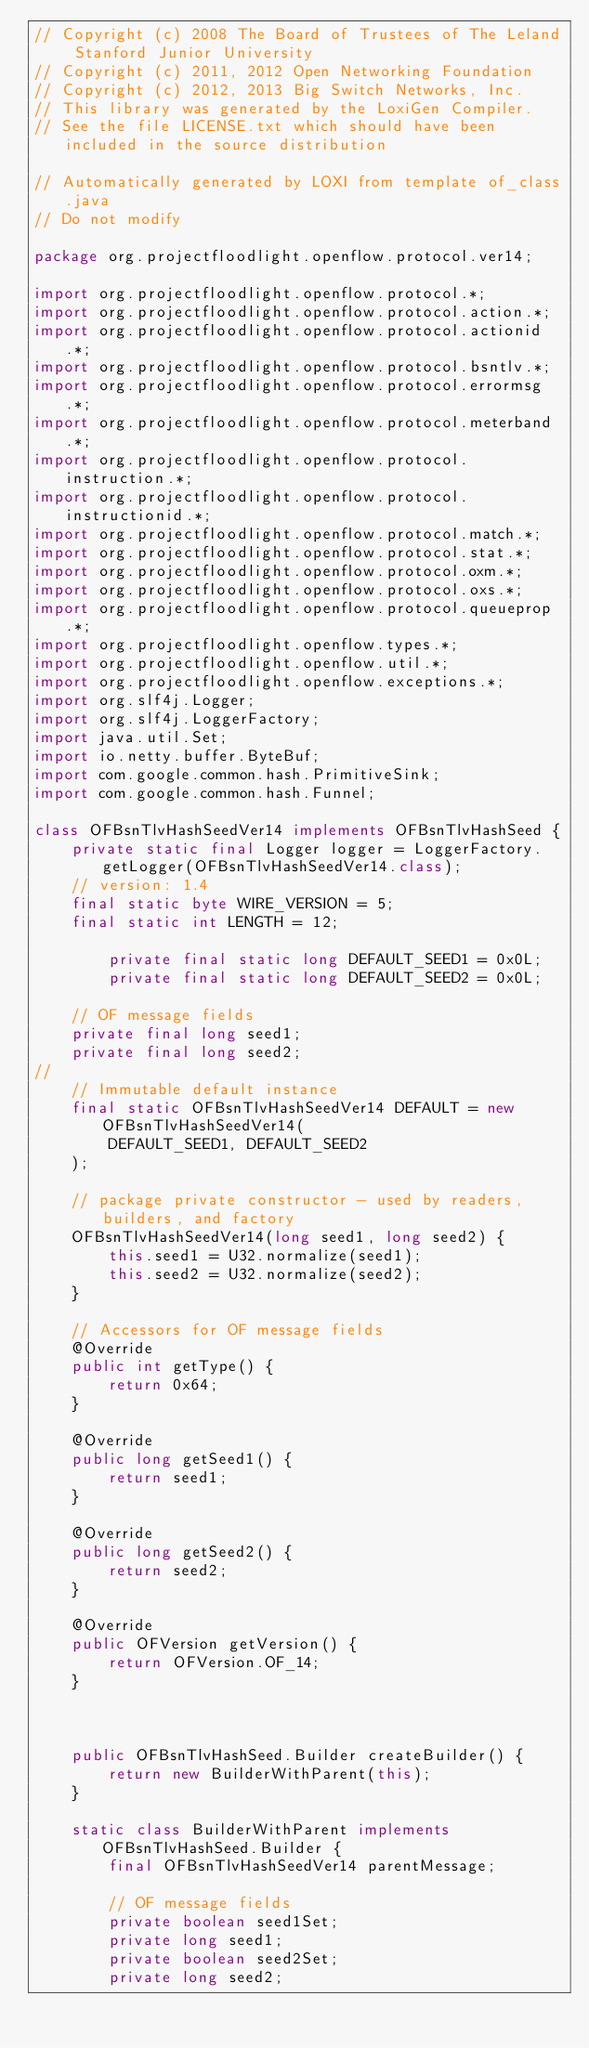<code> <loc_0><loc_0><loc_500><loc_500><_Java_>// Copyright (c) 2008 The Board of Trustees of The Leland Stanford Junior University
// Copyright (c) 2011, 2012 Open Networking Foundation
// Copyright (c) 2012, 2013 Big Switch Networks, Inc.
// This library was generated by the LoxiGen Compiler.
// See the file LICENSE.txt which should have been included in the source distribution

// Automatically generated by LOXI from template of_class.java
// Do not modify

package org.projectfloodlight.openflow.protocol.ver14;

import org.projectfloodlight.openflow.protocol.*;
import org.projectfloodlight.openflow.protocol.action.*;
import org.projectfloodlight.openflow.protocol.actionid.*;
import org.projectfloodlight.openflow.protocol.bsntlv.*;
import org.projectfloodlight.openflow.protocol.errormsg.*;
import org.projectfloodlight.openflow.protocol.meterband.*;
import org.projectfloodlight.openflow.protocol.instruction.*;
import org.projectfloodlight.openflow.protocol.instructionid.*;
import org.projectfloodlight.openflow.protocol.match.*;
import org.projectfloodlight.openflow.protocol.stat.*;
import org.projectfloodlight.openflow.protocol.oxm.*;
import org.projectfloodlight.openflow.protocol.oxs.*;
import org.projectfloodlight.openflow.protocol.queueprop.*;
import org.projectfloodlight.openflow.types.*;
import org.projectfloodlight.openflow.util.*;
import org.projectfloodlight.openflow.exceptions.*;
import org.slf4j.Logger;
import org.slf4j.LoggerFactory;
import java.util.Set;
import io.netty.buffer.ByteBuf;
import com.google.common.hash.PrimitiveSink;
import com.google.common.hash.Funnel;

class OFBsnTlvHashSeedVer14 implements OFBsnTlvHashSeed {
    private static final Logger logger = LoggerFactory.getLogger(OFBsnTlvHashSeedVer14.class);
    // version: 1.4
    final static byte WIRE_VERSION = 5;
    final static int LENGTH = 12;

        private final static long DEFAULT_SEED1 = 0x0L;
        private final static long DEFAULT_SEED2 = 0x0L;

    // OF message fields
    private final long seed1;
    private final long seed2;
//
    // Immutable default instance
    final static OFBsnTlvHashSeedVer14 DEFAULT = new OFBsnTlvHashSeedVer14(
        DEFAULT_SEED1, DEFAULT_SEED2
    );

    // package private constructor - used by readers, builders, and factory
    OFBsnTlvHashSeedVer14(long seed1, long seed2) {
        this.seed1 = U32.normalize(seed1);
        this.seed2 = U32.normalize(seed2);
    }

    // Accessors for OF message fields
    @Override
    public int getType() {
        return 0x64;
    }

    @Override
    public long getSeed1() {
        return seed1;
    }

    @Override
    public long getSeed2() {
        return seed2;
    }

    @Override
    public OFVersion getVersion() {
        return OFVersion.OF_14;
    }



    public OFBsnTlvHashSeed.Builder createBuilder() {
        return new BuilderWithParent(this);
    }

    static class BuilderWithParent implements OFBsnTlvHashSeed.Builder {
        final OFBsnTlvHashSeedVer14 parentMessage;

        // OF message fields
        private boolean seed1Set;
        private long seed1;
        private boolean seed2Set;
        private long seed2;
</code> 